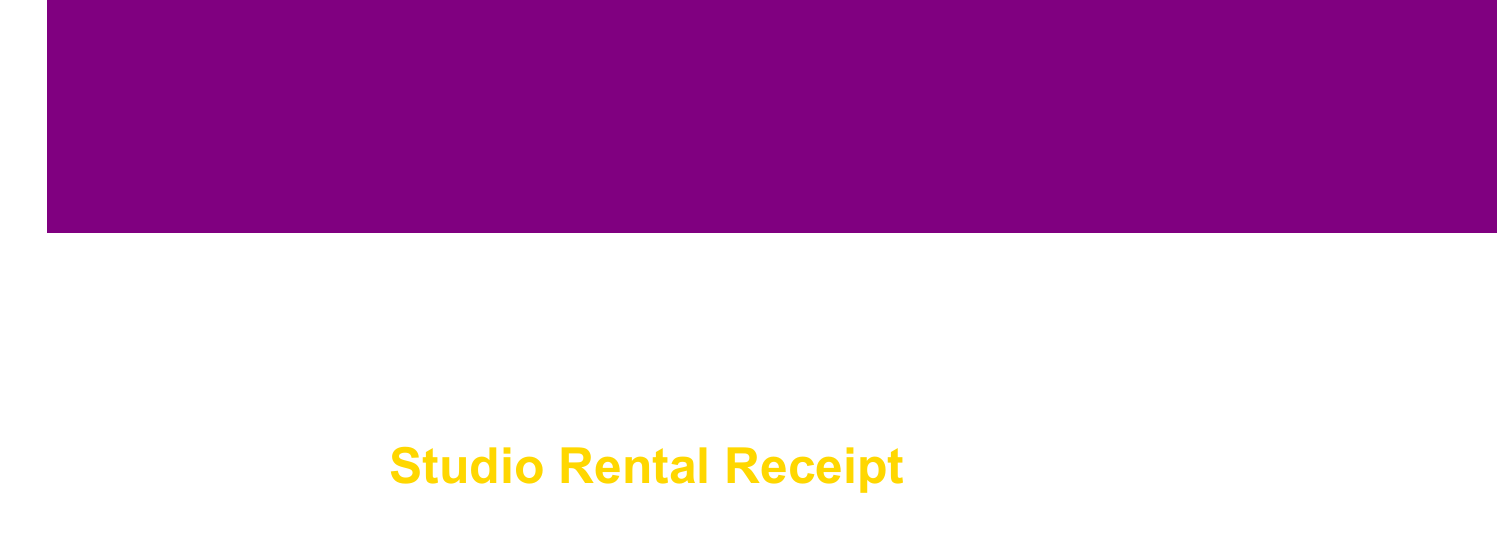What is the name of the studio? The studio's name is clearly mentioned at the top of the receipt.
Answer: Soulful Soundz Studio What is the hourly rate for studio time? The hourly rate for studio time is listed under studio rental details.
Answer: $125/hr How many hours were booked for the recording session? The number of hours booked is specified in the details of the session.
Answer: 8 What was the total amount for additional services? The total amount for additional services can be found by summing the fees of all listed services.
Answer: $350.00 How much was charged for the Neumann U87 Microphone? The fee for the Neumann U87 Microphone is detailed in the equipment used section.
Answer: $400.00 What is the total charge including tax? The total charge is listed at the bottom of the receipt including the calculated tax.
Answer: $1,902.05 How many bottles of water were provided? The quantity of bottled water is listed in the refreshments section.
Answer: 6 What was the note regarding the track 'Funky Nostalgia'? The note is included at the end of the receipt, pointing out a pending issue.
Answer: Soul sample clearance pending for track 'Funky Nostalgia' What method was used for payment? The payment method is mentioned towards the end of the receipt.
Answer: Credit Card 